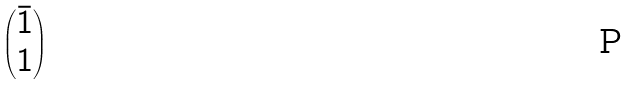Convert formula to latex. <formula><loc_0><loc_0><loc_500><loc_500>\begin{pmatrix} \bar { 1 } \\ 1 \end{pmatrix}</formula> 